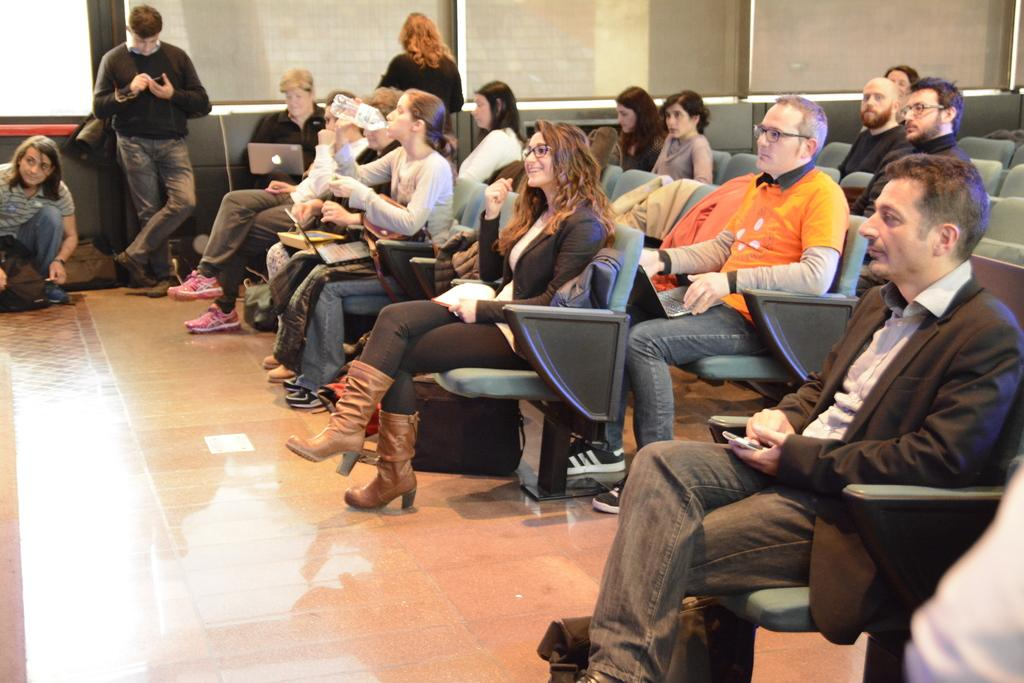What are the people in the image doing? Some people are sitting on chairs, while others are standing in the image. Can you describe the activity of one of the people in the image? There is a person holding a laptop in the image. What type of whistle can be heard in the image? There is no whistle present in the image, and therefore no sound can be heard. 